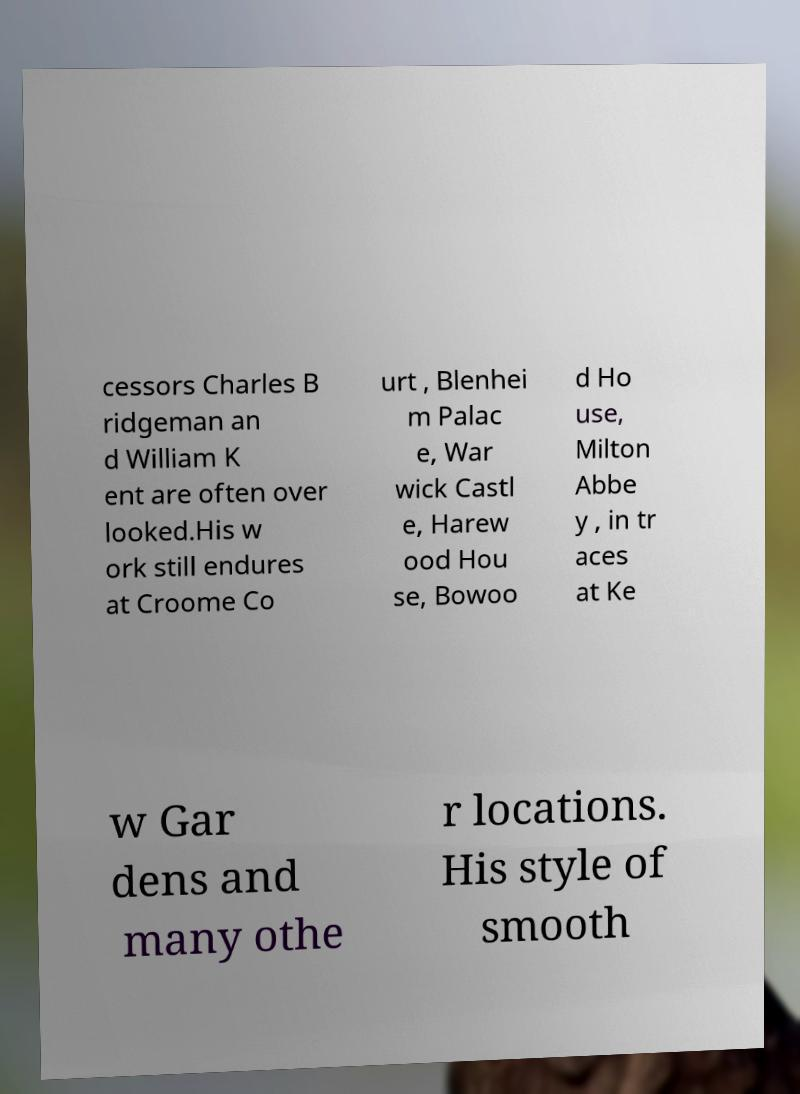Can you read and provide the text displayed in the image?This photo seems to have some interesting text. Can you extract and type it out for me? cessors Charles B ridgeman an d William K ent are often over looked.His w ork still endures at Croome Co urt , Blenhei m Palac e, War wick Castl e, Harew ood Hou se, Bowoo d Ho use, Milton Abbe y , in tr aces at Ke w Gar dens and many othe r locations. His style of smooth 